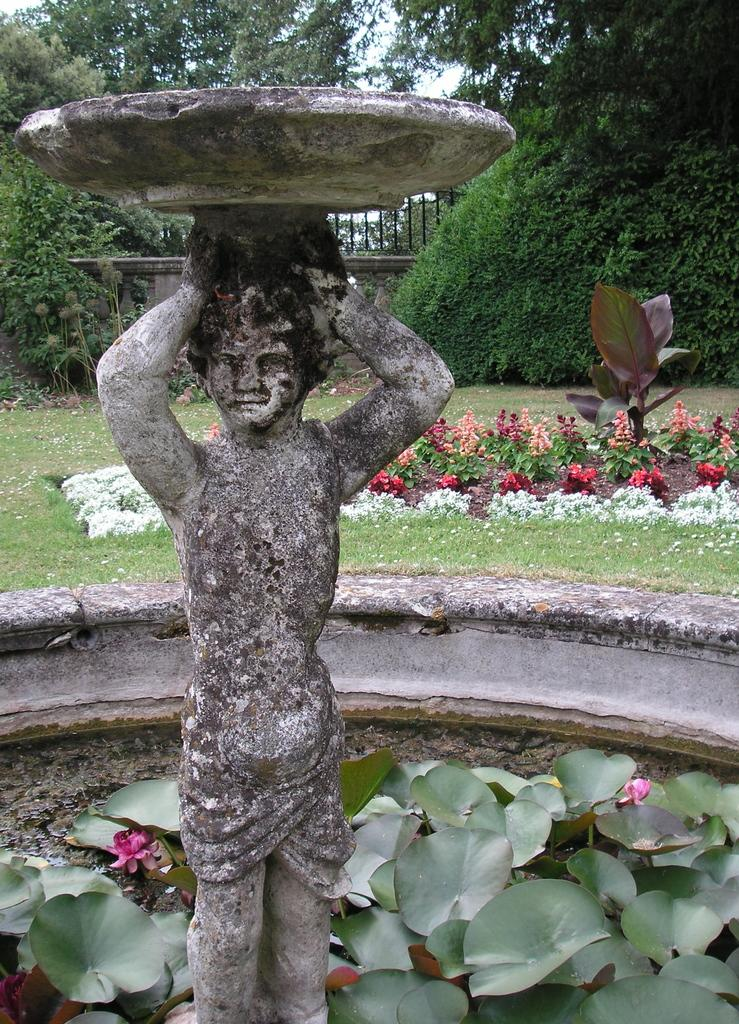What is the main subject in the image? There is a statue in the image. What type of vegetation can be seen in the image? There is grass, plants, flowers, and trees in the image. What architectural feature is present in the image? There is a fence in the image. What can be seen in the background of the image? The sky is visible in the background of the image. What type of meat is being served with the cream on the fork in the image? There is no meat, cream, or fork present in the image. 